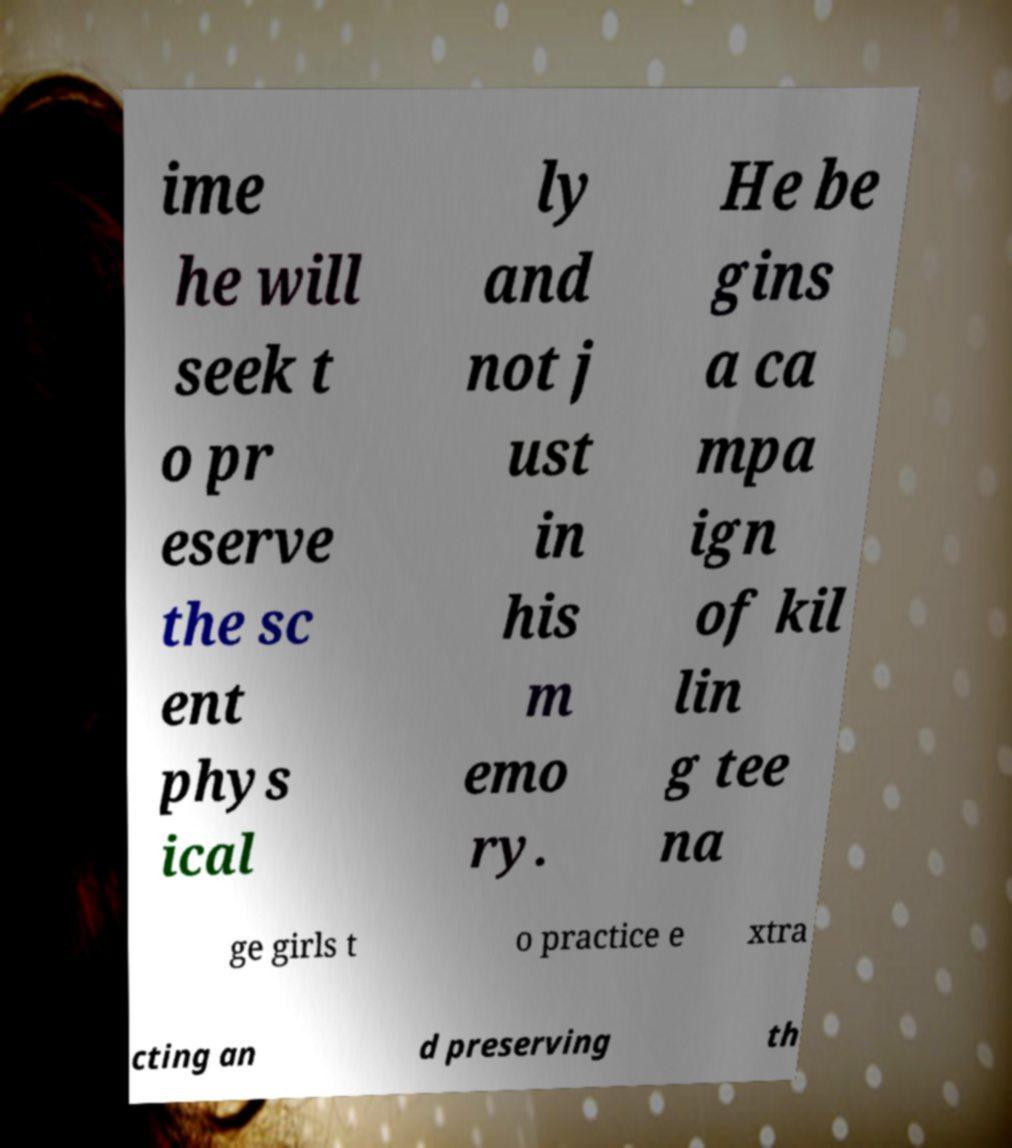I need the written content from this picture converted into text. Can you do that? ime he will seek t o pr eserve the sc ent phys ical ly and not j ust in his m emo ry. He be gins a ca mpa ign of kil lin g tee na ge girls t o practice e xtra cting an d preserving th 